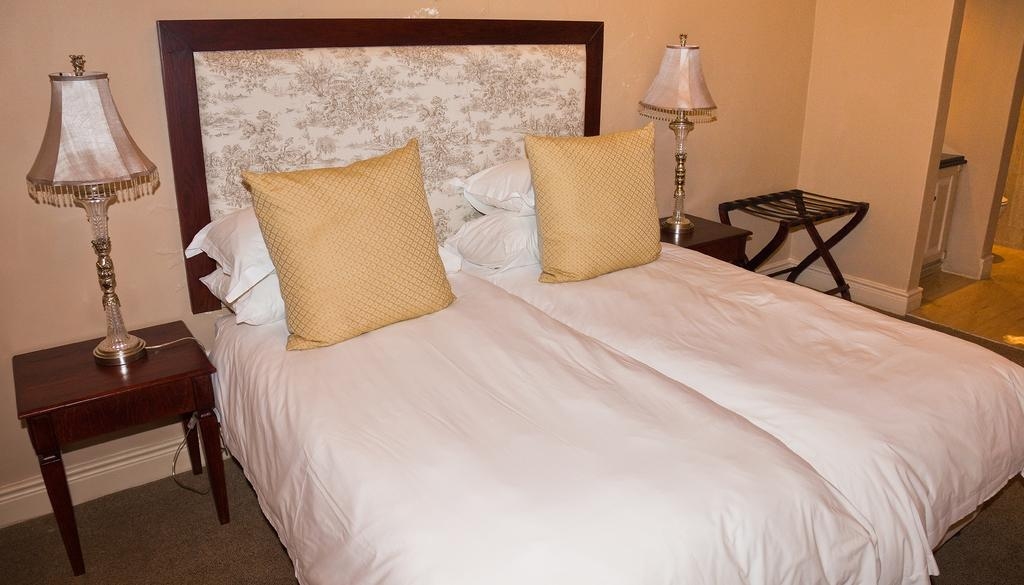What piece of furniture is present in the image? There is a bed in the image. What is covering the bed? The bed is covered with a white blanket. What are some items that can be used for support while sleeping on the bed? There are pillows and cushions on the bed. What other piece of furniture is present in the image? There is a table in the image. What is on the table? There is a lamp on the table. What degree of warmth does the kitten provide on the bed in the image? There is no kitten present in the image, so it cannot provide warmth on the bed. 